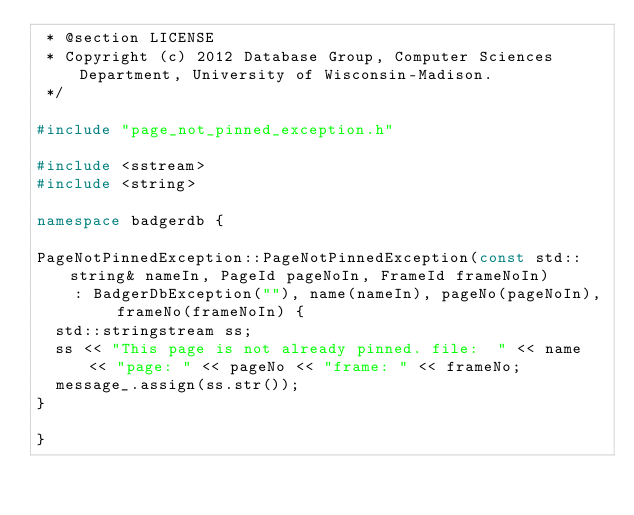<code> <loc_0><loc_0><loc_500><loc_500><_C++_> * @section LICENSE
 * Copyright (c) 2012 Database Group, Computer Sciences Department, University of Wisconsin-Madison.
 */

#include "page_not_pinned_exception.h"

#include <sstream>
#include <string>

namespace badgerdb {

PageNotPinnedException::PageNotPinnedException(const std::string& nameIn, PageId pageNoIn, FrameId frameNoIn)
    : BadgerDbException(""), name(nameIn), pageNo(pageNoIn), frameNo(frameNoIn) {
  std::stringstream ss;
  ss << "This page is not already pinned. file:  " << name << "page: " << pageNo << "frame: " << frameNo;
  message_.assign(ss.str());
}

}
</code> 